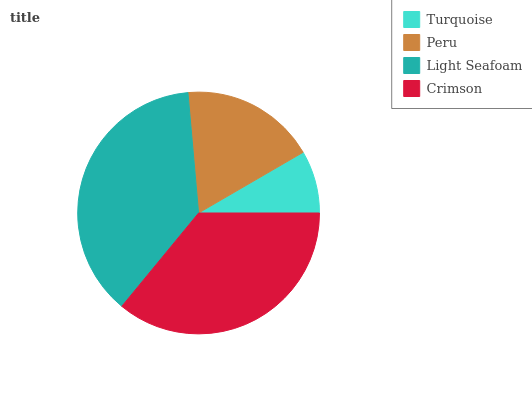Is Turquoise the minimum?
Answer yes or no. Yes. Is Light Seafoam the maximum?
Answer yes or no. Yes. Is Peru the minimum?
Answer yes or no. No. Is Peru the maximum?
Answer yes or no. No. Is Peru greater than Turquoise?
Answer yes or no. Yes. Is Turquoise less than Peru?
Answer yes or no. Yes. Is Turquoise greater than Peru?
Answer yes or no. No. Is Peru less than Turquoise?
Answer yes or no. No. Is Crimson the high median?
Answer yes or no. Yes. Is Peru the low median?
Answer yes or no. Yes. Is Peru the high median?
Answer yes or no. No. Is Turquoise the low median?
Answer yes or no. No. 